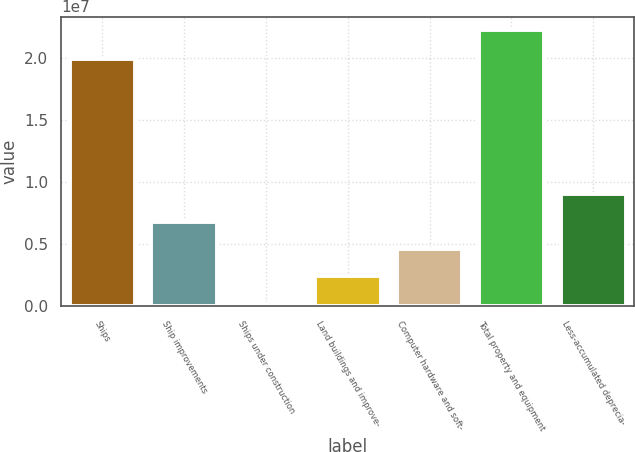<chart> <loc_0><loc_0><loc_500><loc_500><bar_chart><fcel>Ships<fcel>Ship improvements<fcel>Ships under construction<fcel>Land buildings and improve-<fcel>Computer hardware and soft-<fcel>Total property and equipment<fcel>Less-accumulated deprecia-<nl><fcel>1.99581e+07<fcel>6.84002e+06<fcel>227123<fcel>2.43142e+06<fcel>4.63572e+06<fcel>2.22701e+07<fcel>9.04432e+06<nl></chart> 